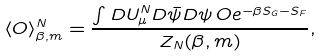<formula> <loc_0><loc_0><loc_500><loc_500>\langle O \rangle ^ { N } _ { \beta , m } = \frac { \int D U ^ { N } _ { \mu } D \bar { \psi } D \psi \, O e ^ { - \beta S _ { G } - S _ { F } } } { Z _ { N } ( \beta , m ) } ,</formula> 